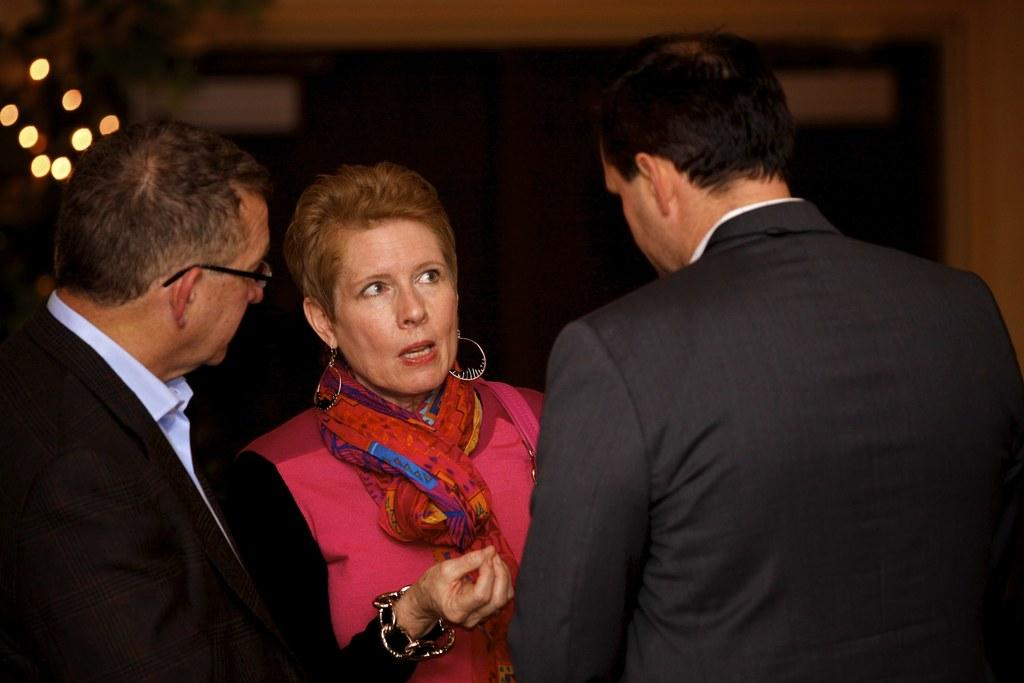What are the people in the image doing? The people in the image are standing in the center. Can you describe any specific features of one of the people? One of the people is wearing glasses. What can be seen in the background of the image? There are lights and a wall in the background of the image. What type of bait is being used to attract the geese in the image? There are no geese or bait present in the image. What organization is responsible for the event taking place in the image? There is no indication of an event or organization in the image. 